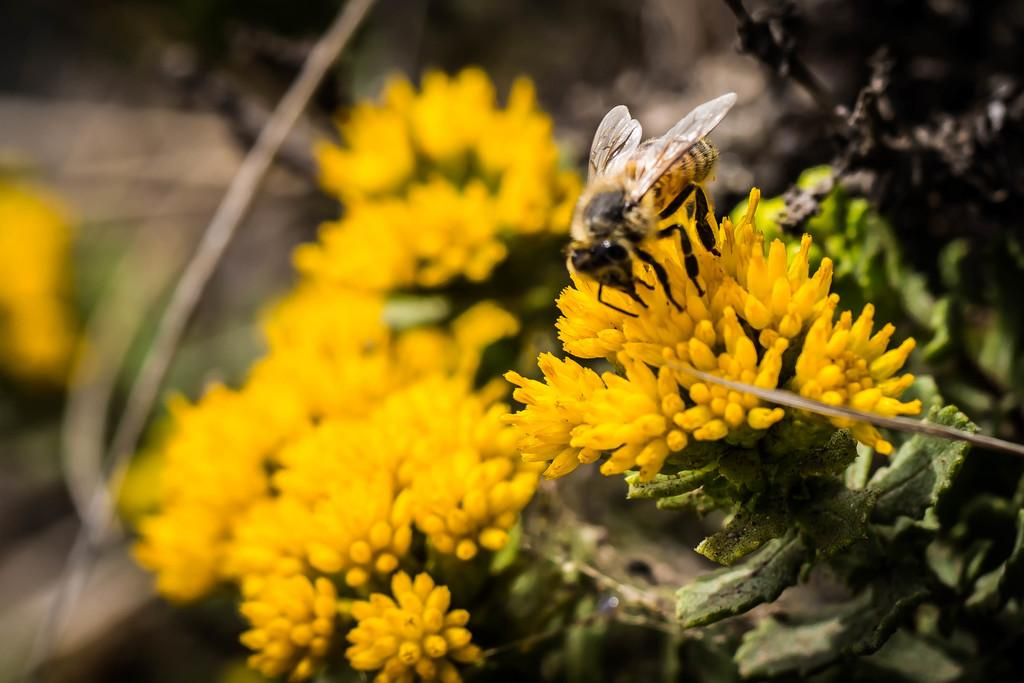What is in the foreground of the image? There are flowers in the foreground of the image. Is there any wildlife interacting with the flowers? Yes, there is a bee on the flowers. How would you describe the background of the image? The background of the image is blurry. What type of rice can be seen in the image? There is no rice present in the image; it features flowers and a bee. Is there any reason to believe that the flowers are fake in the image? There is no information provided about the authenticity of the flowers, so it cannot be determined whether they are real or fake. 